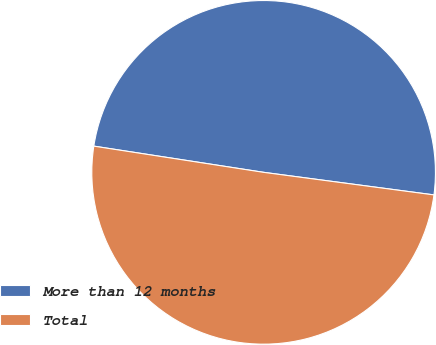Convert chart. <chart><loc_0><loc_0><loc_500><loc_500><pie_chart><fcel>More than 12 months<fcel>Total<nl><fcel>49.66%<fcel>50.34%<nl></chart> 